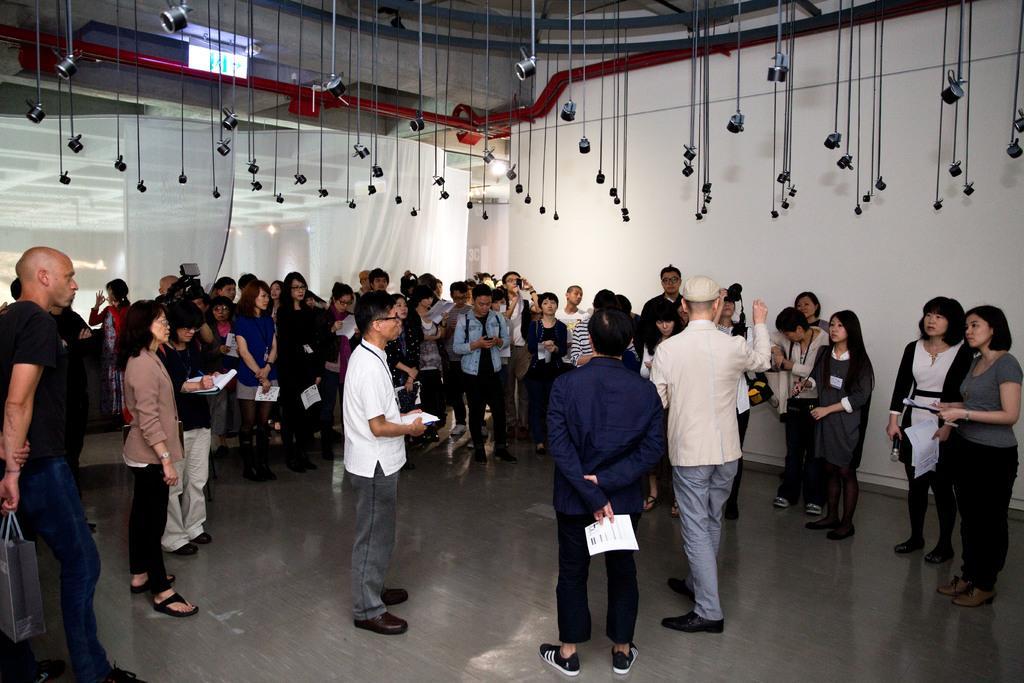In one or two sentences, can you explain what this image depicts? In this picture we can see some people standing here, some of them are holding papers, in the background there is a wall, we can see curtains here, at the bottom there is floor. 